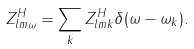<formula> <loc_0><loc_0><loc_500><loc_500>Z ^ { H } _ { l m \omega } = \sum _ { k } Z ^ { H } _ { l m k } \delta ( \omega - \omega _ { k } ) .</formula> 